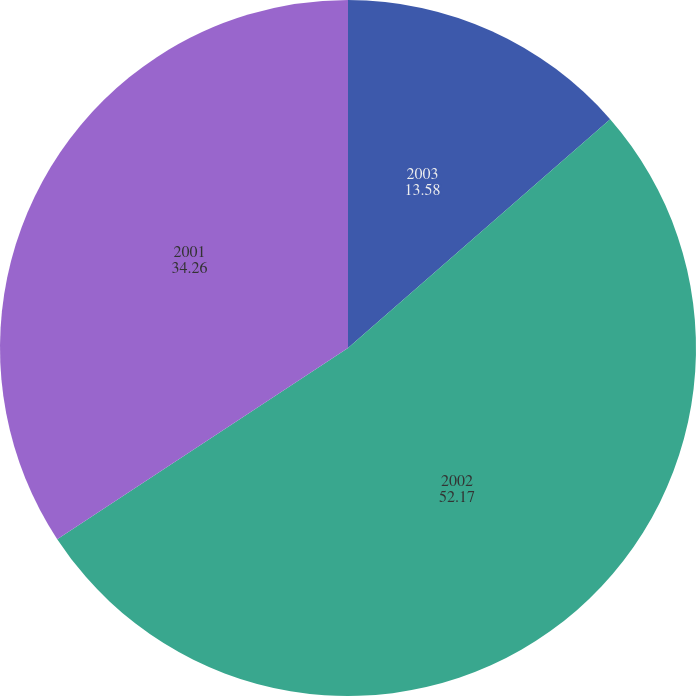<chart> <loc_0><loc_0><loc_500><loc_500><pie_chart><fcel>2003<fcel>2002<fcel>2001<nl><fcel>13.58%<fcel>52.17%<fcel>34.26%<nl></chart> 